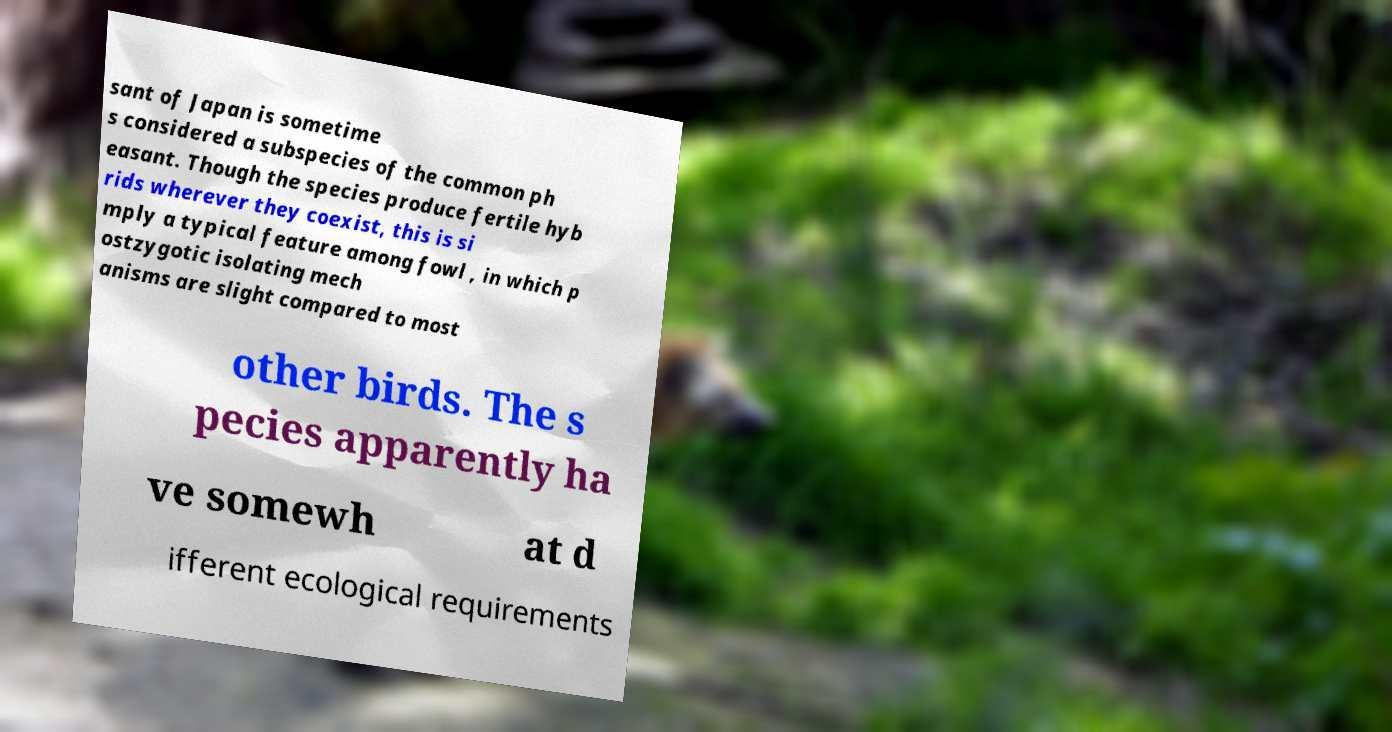Please identify and transcribe the text found in this image. sant of Japan is sometime s considered a subspecies of the common ph easant. Though the species produce fertile hyb rids wherever they coexist, this is si mply a typical feature among fowl , in which p ostzygotic isolating mech anisms are slight compared to most other birds. The s pecies apparently ha ve somewh at d ifferent ecological requirements 